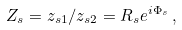<formula> <loc_0><loc_0><loc_500><loc_500>Z _ { s } = z _ { s 1 } / z _ { s 2 } = R _ { s } e ^ { i \Phi _ { s } } \, ,</formula> 